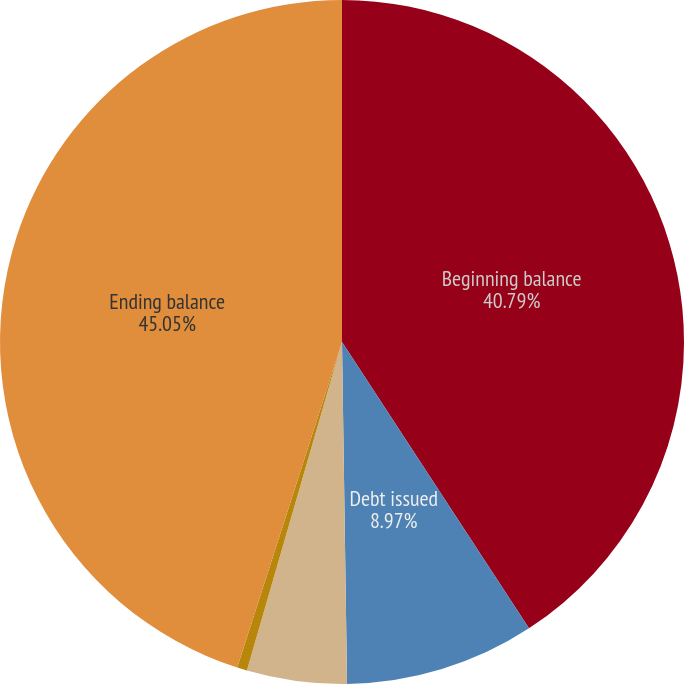<chart> <loc_0><loc_0><loc_500><loc_500><pie_chart><fcel>Beginning balance<fcel>Debt issued<fcel>Debt extinguished<fcel>Foreign currency<fcel>Ending balance<nl><fcel>40.79%<fcel>8.97%<fcel>4.72%<fcel>0.47%<fcel>45.04%<nl></chart> 